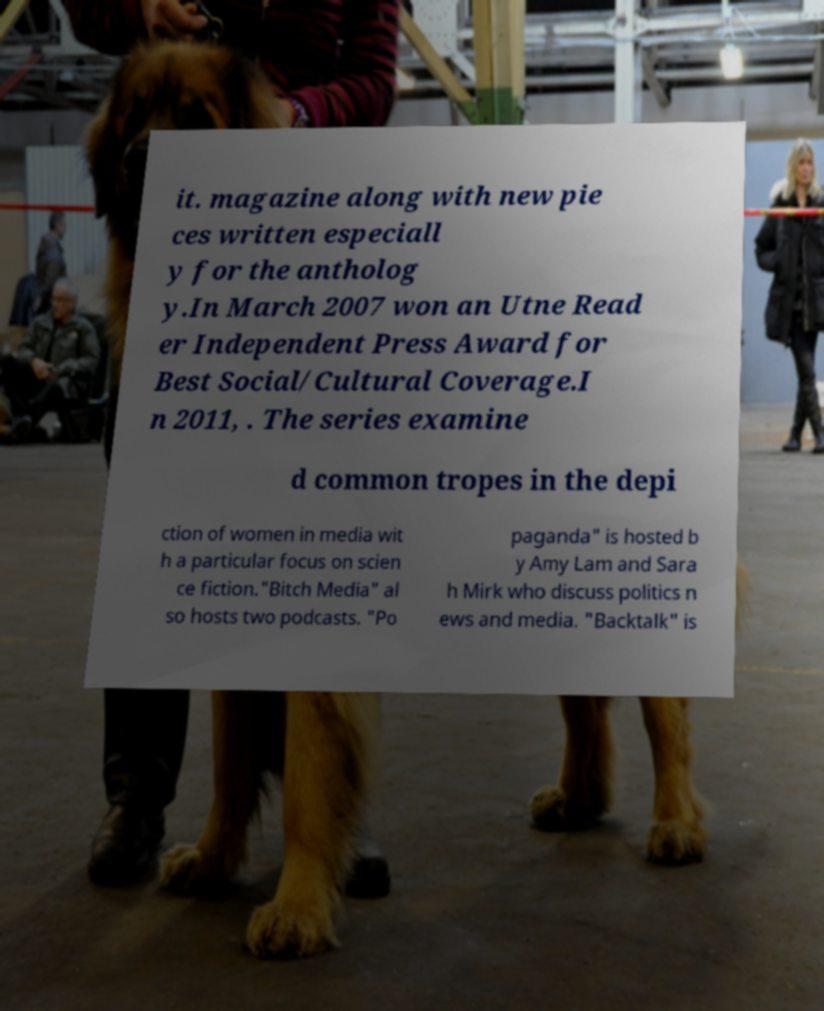Please read and relay the text visible in this image. What does it say? it. magazine along with new pie ces written especiall y for the antholog y.In March 2007 won an Utne Read er Independent Press Award for Best Social/Cultural Coverage.I n 2011, . The series examine d common tropes in the depi ction of women in media wit h a particular focus on scien ce fiction."Bitch Media" al so hosts two podcasts. "Po paganda" is hosted b y Amy Lam and Sara h Mirk who discuss politics n ews and media. "Backtalk" is 